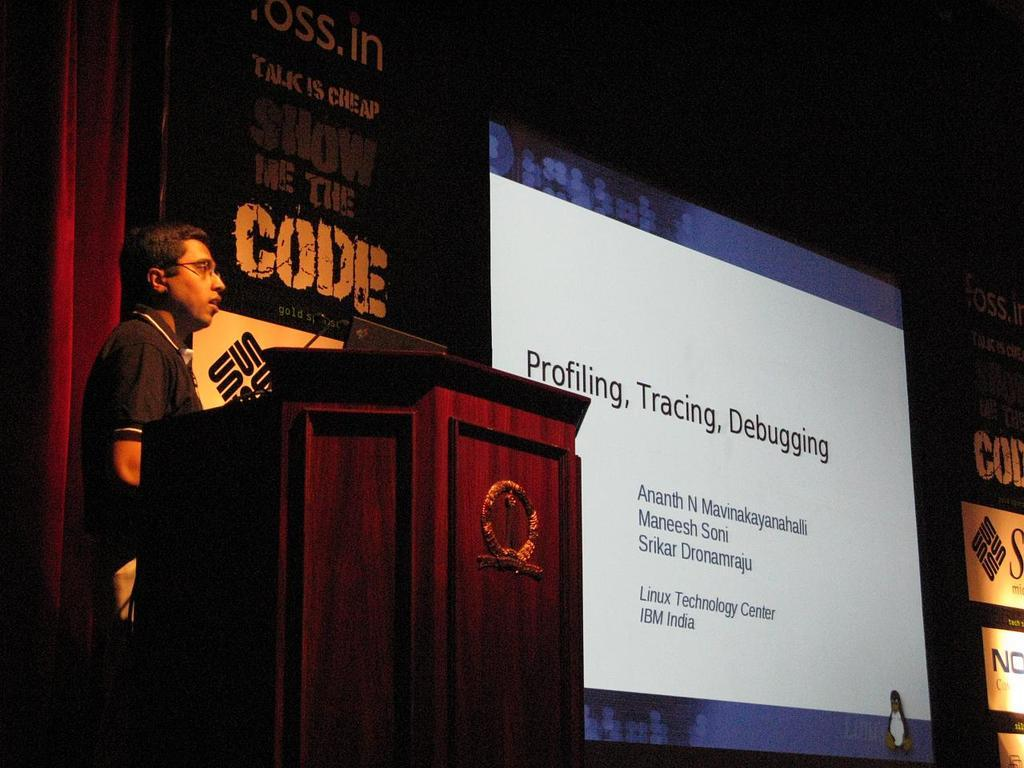What is the person in the image doing? The person is standing behind a wooden podium. What electronic device is visible in the image? A laptop is visible in the image. What is used for amplifying the person's voice in the image? A microphone is present in the image. What can be seen in the background of the image? There is a screen, a curtain, and banners in the background. How would you describe the lighting in the background of the image? The background has a dark view. What type of fowl can be seen flying in the background of the image? There are no fowl visible in the image; the background features a screen, curtain, and banners. 